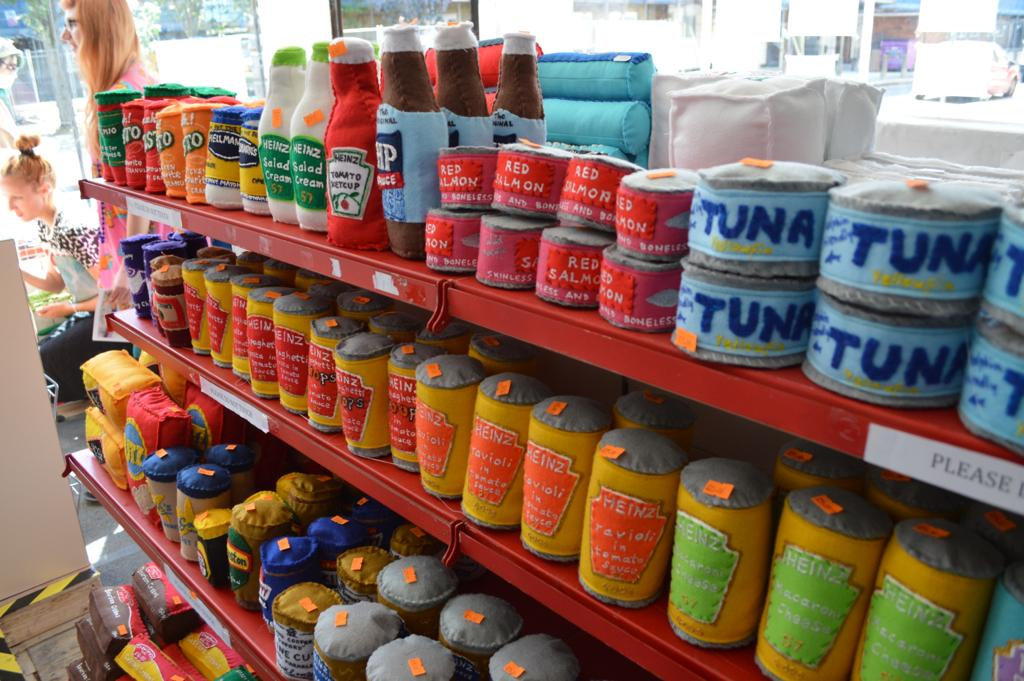<image>
Summarize the visual content of the image. A toy grocery aisle featuring products such as Heinz ketchup and Hellman's mayonnaise. 